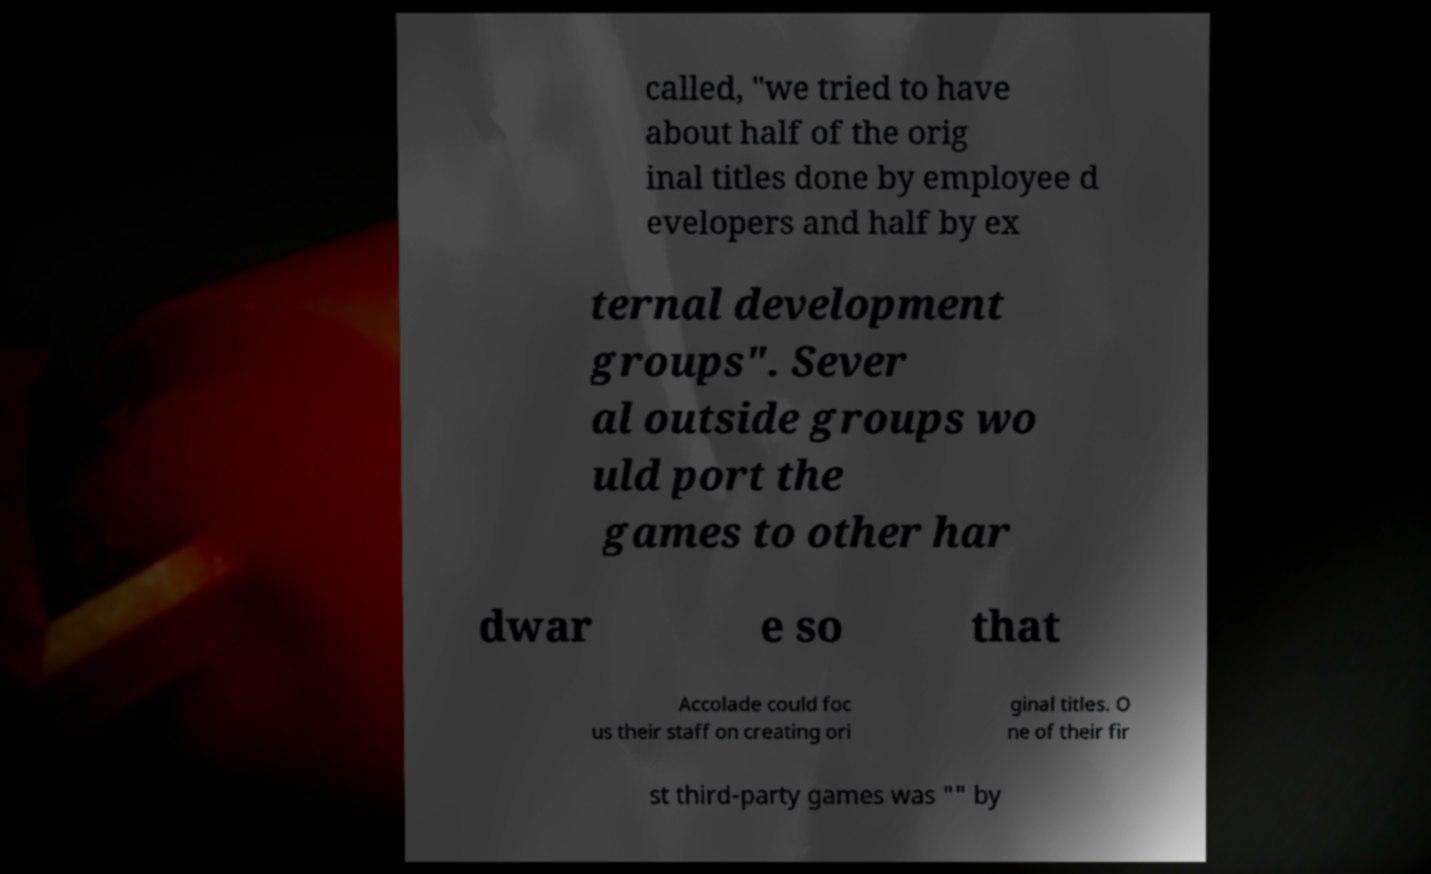Please identify and transcribe the text found in this image. called, "we tried to have about half of the orig inal titles done by employee d evelopers and half by ex ternal development groups". Sever al outside groups wo uld port the games to other har dwar e so that Accolade could foc us their staff on creating ori ginal titles. O ne of their fir st third-party games was "" by 